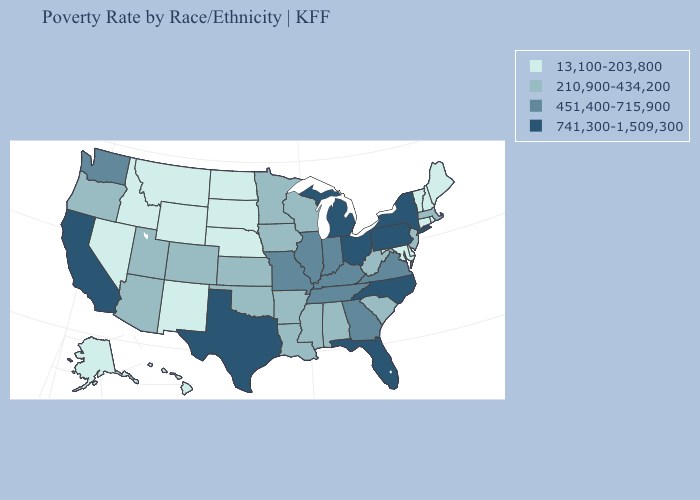What is the highest value in the MidWest ?
Answer briefly. 741,300-1,509,300. Which states hav the highest value in the Northeast?
Short answer required. New York, Pennsylvania. Which states have the highest value in the USA?
Keep it brief. California, Florida, Michigan, New York, North Carolina, Ohio, Pennsylvania, Texas. What is the highest value in the USA?
Concise answer only. 741,300-1,509,300. Among the states that border Arkansas , which have the lowest value?
Be succinct. Louisiana, Mississippi, Oklahoma. How many symbols are there in the legend?
Short answer required. 4. How many symbols are there in the legend?
Concise answer only. 4. Name the states that have a value in the range 210,900-434,200?
Quick response, please. Alabama, Arizona, Arkansas, Colorado, Iowa, Kansas, Louisiana, Massachusetts, Minnesota, Mississippi, New Jersey, Oklahoma, Oregon, South Carolina, Utah, West Virginia, Wisconsin. Name the states that have a value in the range 451,400-715,900?
Concise answer only. Georgia, Illinois, Indiana, Kentucky, Missouri, Tennessee, Virginia, Washington. Does the first symbol in the legend represent the smallest category?
Short answer required. Yes. What is the value of Minnesota?
Write a very short answer. 210,900-434,200. What is the lowest value in states that border Nebraska?
Give a very brief answer. 13,100-203,800. What is the lowest value in states that border Illinois?
Short answer required. 210,900-434,200. Does the first symbol in the legend represent the smallest category?
Answer briefly. Yes. What is the value of Nebraska?
Answer briefly. 13,100-203,800. 